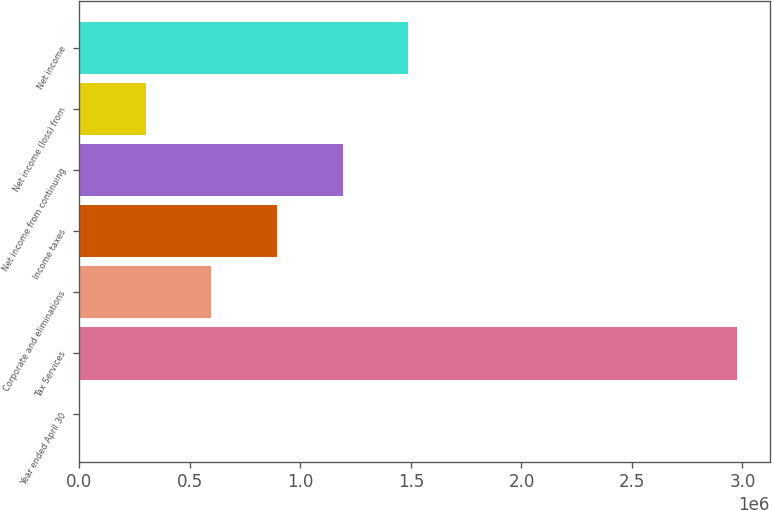<chart> <loc_0><loc_0><loc_500><loc_500><bar_chart><fcel>Year ended April 30<fcel>Tax Services<fcel>Corporate and eliminations<fcel>Income taxes<fcel>Net income from continuing<fcel>Net income (loss) from<fcel>Net income<nl><fcel>2010<fcel>2.97525e+06<fcel>596658<fcel>893983<fcel>1.19131e+06<fcel>299334<fcel>1.48863e+06<nl></chart> 